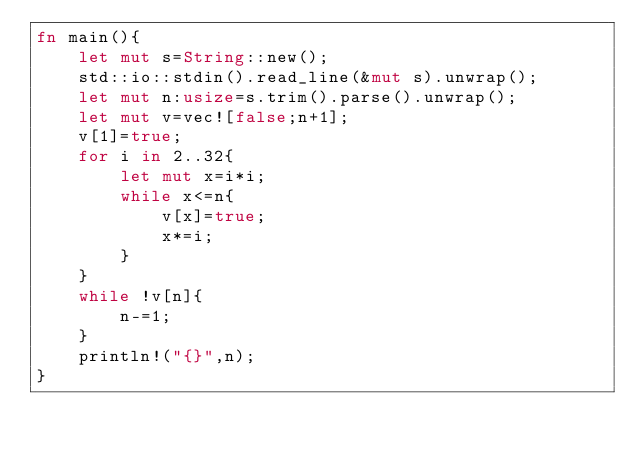Convert code to text. <code><loc_0><loc_0><loc_500><loc_500><_Rust_>fn main(){
    let mut s=String::new();
    std::io::stdin().read_line(&mut s).unwrap();
    let mut n:usize=s.trim().parse().unwrap();
    let mut v=vec![false;n+1];
    v[1]=true;
    for i in 2..32{
        let mut x=i*i;
        while x<=n{
            v[x]=true;
            x*=i;
        }
    }
    while !v[n]{
        n-=1;
    }
    println!("{}",n);
}</code> 